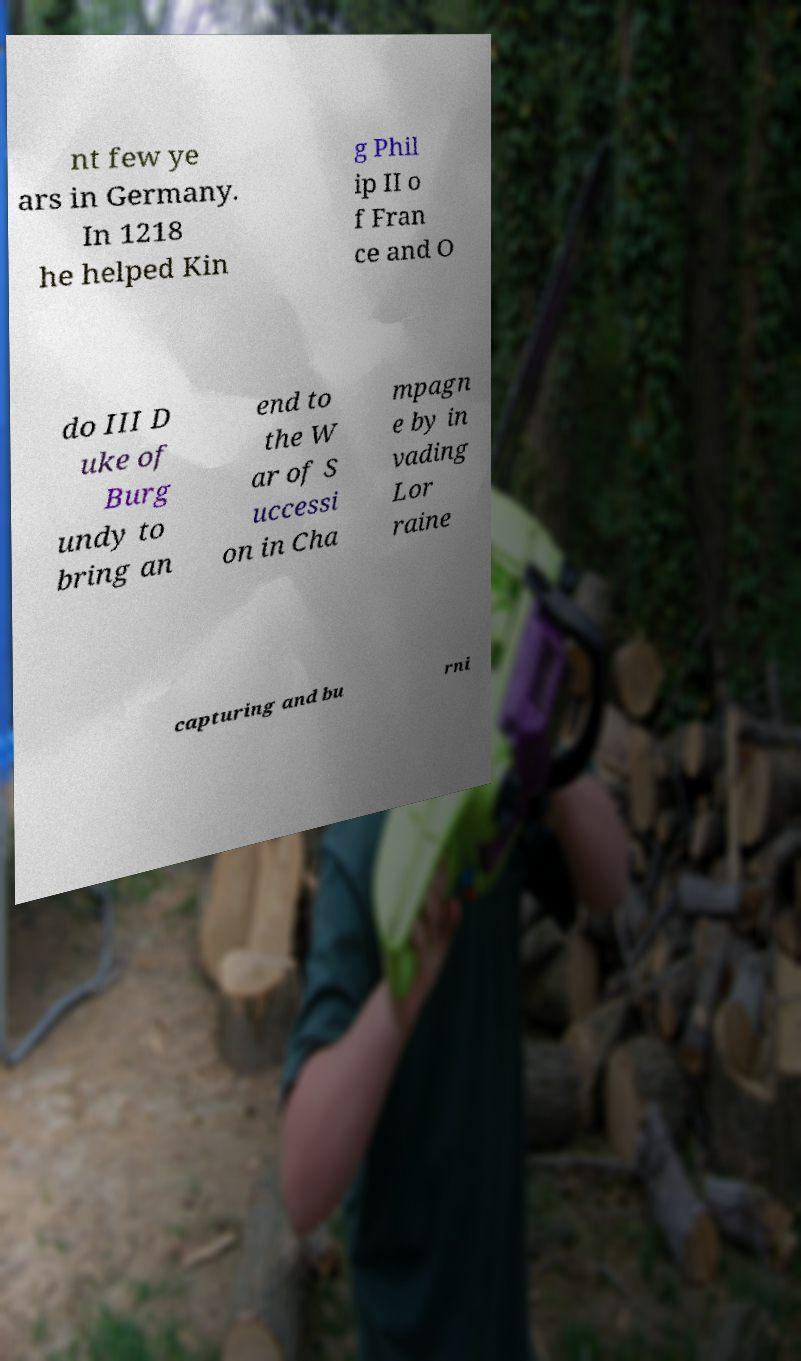For documentation purposes, I need the text within this image transcribed. Could you provide that? nt few ye ars in Germany. In 1218 he helped Kin g Phil ip II o f Fran ce and O do III D uke of Burg undy to bring an end to the W ar of S uccessi on in Cha mpagn e by in vading Lor raine capturing and bu rni 